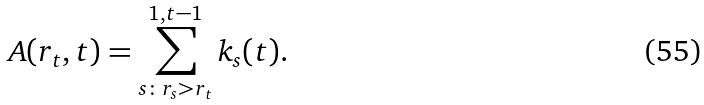Convert formula to latex. <formula><loc_0><loc_0><loc_500><loc_500>A ( r _ { t } , t ) = \sum _ { s \colon r _ { s } > r _ { t } } ^ { 1 , t - 1 } k _ { s } ( t ) .</formula> 